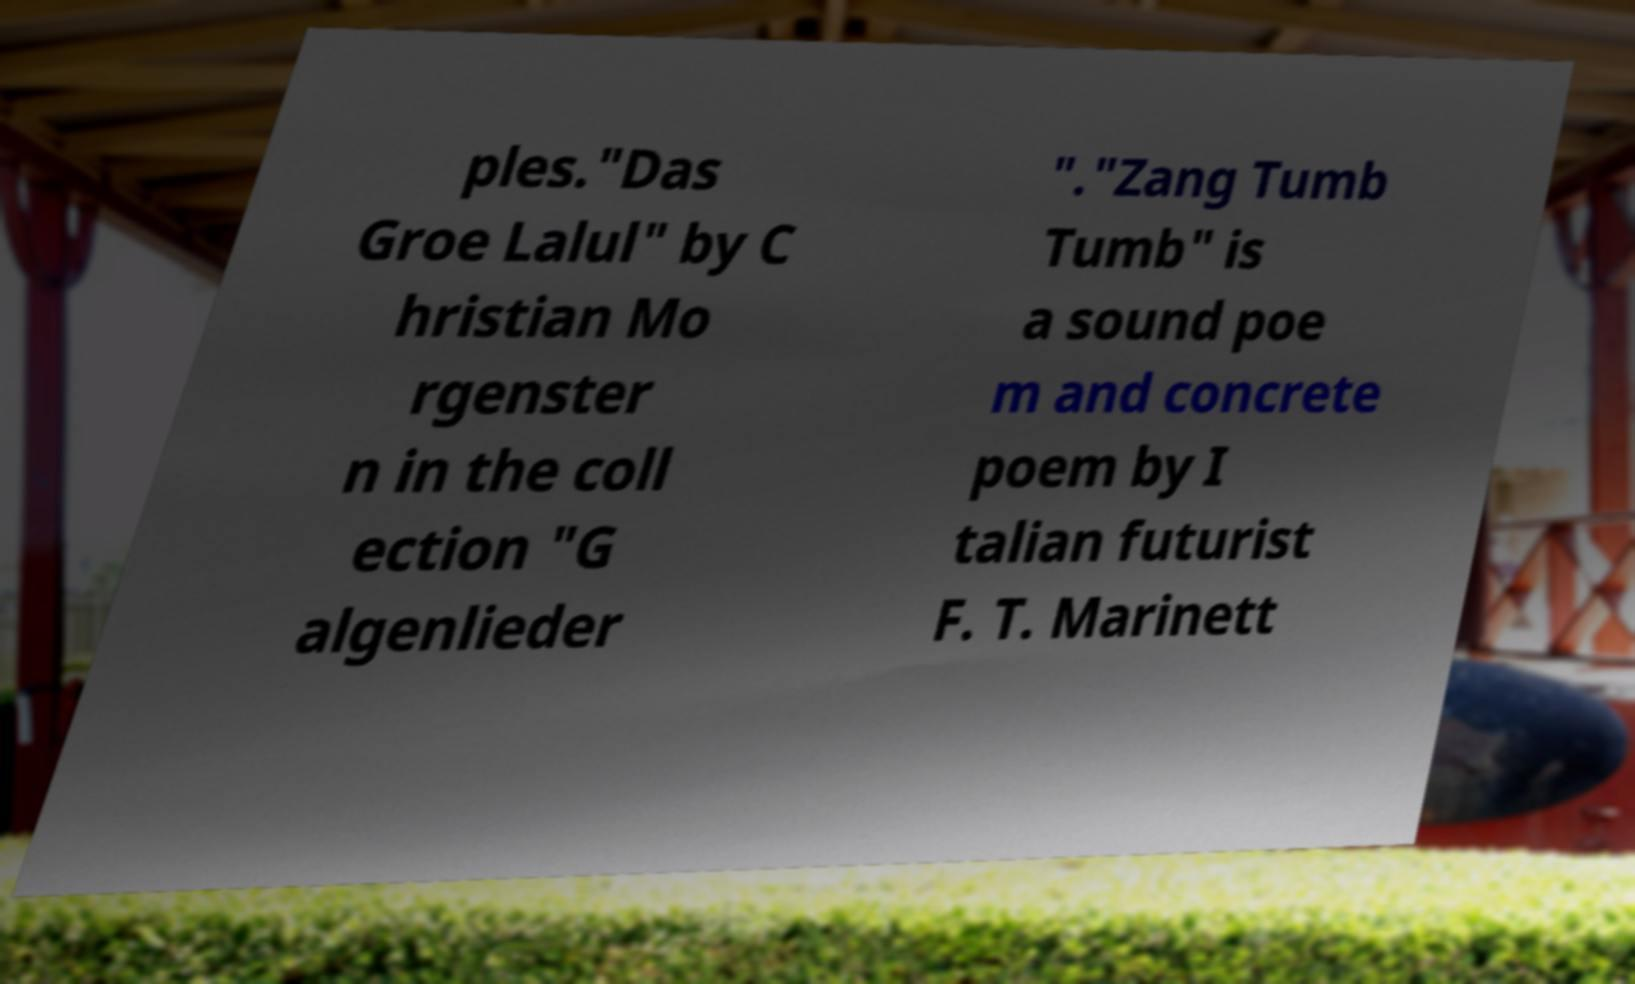Can you accurately transcribe the text from the provided image for me? ples."Das Groe Lalul" by C hristian Mo rgenster n in the coll ection "G algenlieder "."Zang Tumb Tumb" is a sound poe m and concrete poem by I talian futurist F. T. Marinett 